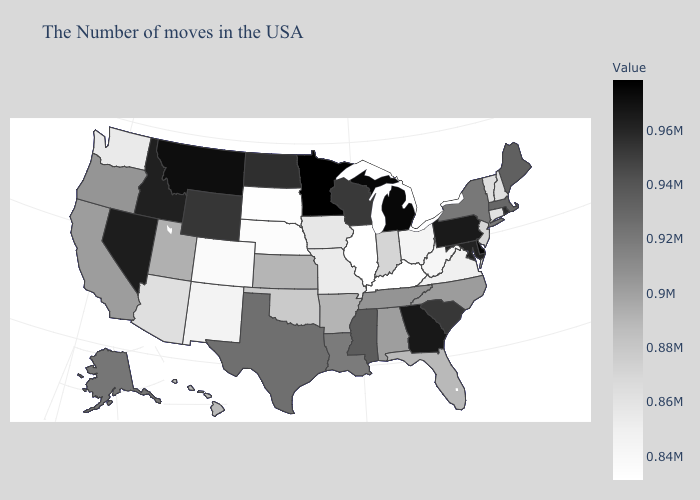Among the states that border Ohio , which have the lowest value?
Concise answer only. Kentucky. Does Illinois have the lowest value in the USA?
Answer briefly. Yes. Is the legend a continuous bar?
Concise answer only. Yes. Does Pennsylvania have the lowest value in the USA?
Answer briefly. No. Among the states that border Colorado , which have the highest value?
Quick response, please. Wyoming. 